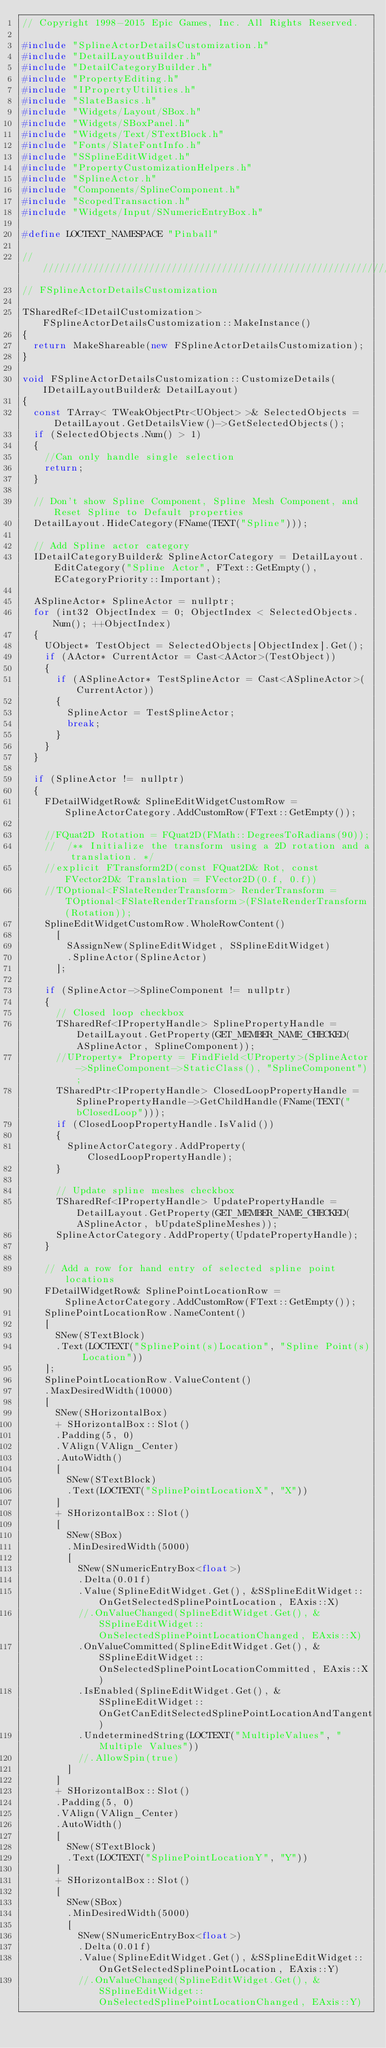Convert code to text. <code><loc_0><loc_0><loc_500><loc_500><_C++_>// Copyright 1998-2015 Epic Games, Inc. All Rights Reserved.

#include "SplineActorDetailsCustomization.h"
#include "DetailLayoutBuilder.h"
#include "DetailCategoryBuilder.h"
#include "PropertyEditing.h"
#include "IPropertyUtilities.h"
#include "SlateBasics.h"
#include "Widgets/Layout/SBox.h"
#include "Widgets/SBoxPanel.h"
#include "Widgets/Text/STextBlock.h"
#include "Fonts/SlateFontInfo.h"
#include "SSplineEditWidget.h"
#include "PropertyCustomizationHelpers.h"
#include "SplineActor.h"
#include "Components/SplineComponent.h"
#include "ScopedTransaction.h"
#include "Widgets/Input/SNumericEntryBox.h"

#define LOCTEXT_NAMESPACE "Pinball"

//////////////////////////////////////////////////////////////////////////
// FSplineActorDetailsCustomization

TSharedRef<IDetailCustomization> FSplineActorDetailsCustomization::MakeInstance()
{
	return MakeShareable(new FSplineActorDetailsCustomization);
}

void FSplineActorDetailsCustomization::CustomizeDetails(IDetailLayoutBuilder& DetailLayout)
{
	const TArray< TWeakObjectPtr<UObject> >& SelectedObjects = DetailLayout.GetDetailsView()->GetSelectedObjects();
	if (SelectedObjects.Num() > 1)
	{
		//Can only handle single selection
		return;
	}

	// Don't show Spline Component, Spline Mesh Component, and Reset Spline to Default properties
	DetailLayout.HideCategory(FName(TEXT("Spline")));

	// Add Spline actor category
	IDetailCategoryBuilder& SplineActorCategory = DetailLayout.EditCategory("Spline Actor", FText::GetEmpty(), ECategoryPriority::Important);

	ASplineActor* SplineActor = nullptr;
	for (int32 ObjectIndex = 0; ObjectIndex < SelectedObjects.Num(); ++ObjectIndex)
	{
		UObject* TestObject = SelectedObjects[ObjectIndex].Get();
		if (AActor* CurrentActor = Cast<AActor>(TestObject))
		{
			if (ASplineActor* TestSplineActor = Cast<ASplineActor>(CurrentActor))
			{
				SplineActor = TestSplineActor;
				break;
			}
		}
	}

	if (SplineActor != nullptr)
	{
		FDetailWidgetRow& SplineEditWidgetCustomRow = SplineActorCategory.AddCustomRow(FText::GetEmpty());

		//FQuat2D Rotation = FQuat2D(FMath::DegreesToRadians(90));
		//	/** Initialize the transform using a 2D rotation and a translation. */
		//explicit FTransform2D(const FQuat2D& Rot, const FVector2D& Translation = FVector2D(0.f, 0.f))
		//TOptional<FSlateRenderTransform> RenderTransform = TOptional<FSlateRenderTransform>(FSlateRenderTransform(Rotation));
		SplineEditWidgetCustomRow.WholeRowContent()
			[
				SAssignNew(SplineEditWidget, SSplineEditWidget)
				.SplineActor(SplineActor)
			];

		if (SplineActor->SplineComponent != nullptr)
		{
			// Closed loop checkbox
			TSharedRef<IPropertyHandle> SplinePropertyHandle = DetailLayout.GetProperty(GET_MEMBER_NAME_CHECKED(ASplineActor, SplineComponent));
			//UProperty* Property = FindField<UProperty>(SplineActor->SplineComponent->StaticClass(), "SplineComponent");
			TSharedPtr<IPropertyHandle> ClosedLoopPropertyHandle = SplinePropertyHandle->GetChildHandle(FName(TEXT("bClosedLoop")));
			if (ClosedLoopPropertyHandle.IsValid())
			{
				SplineActorCategory.AddProperty(ClosedLoopPropertyHandle);
			}

			// Update spline meshes checkbox
			TSharedRef<IPropertyHandle> UpdatePropertyHandle = DetailLayout.GetProperty(GET_MEMBER_NAME_CHECKED(ASplineActor, bUpdateSplineMeshes));
			SplineActorCategory.AddProperty(UpdatePropertyHandle);
		}

		// Add a row for hand entry of selected spline point locations
		FDetailWidgetRow& SplinePointLocationRow = SplineActorCategory.AddCustomRow(FText::GetEmpty());
		SplinePointLocationRow.NameContent()
		[
			SNew(STextBlock)
			.Text(LOCTEXT("SplinePoint(s)Location", "Spline Point(s) Location"))
		];
		SplinePointLocationRow.ValueContent()
		.MaxDesiredWidth(10000)
		[
			SNew(SHorizontalBox)
			+ SHorizontalBox::Slot()
			.Padding(5, 0)
			.VAlign(VAlign_Center)
			.AutoWidth()
			[
				SNew(STextBlock)
				.Text(LOCTEXT("SplinePointLocationX", "X"))
			]
			+ SHorizontalBox::Slot()
			[
				SNew(SBox)
				.MinDesiredWidth(5000)
				[
					SNew(SNumericEntryBox<float>)
					.Delta(0.01f)
					.Value(SplineEditWidget.Get(), &SSplineEditWidget::OnGetSelectedSplinePointLocation, EAxis::X)
					//.OnValueChanged(SplineEditWidget.Get(), &SSplineEditWidget::OnSelectedSplinePointLocationChanged, EAxis::X)
					.OnValueCommitted(SplineEditWidget.Get(), &SSplineEditWidget::OnSelectedSplinePointLocationCommitted, EAxis::X)
					.IsEnabled(SplineEditWidget.Get(), &SSplineEditWidget::OnGetCanEditSelectedSplinePointLocationAndTangent)
					.UndeterminedString(LOCTEXT("MultipleValues", "Multiple Values"))
					//.AllowSpin(true)
				]
			]
			+ SHorizontalBox::Slot()
			.Padding(5, 0)
			.VAlign(VAlign_Center)
			.AutoWidth()
			[
				SNew(STextBlock)
				.Text(LOCTEXT("SplinePointLocationY", "Y"))
			]
			+ SHorizontalBox::Slot()
			[
				SNew(SBox)
				.MinDesiredWidth(5000)
				[
					SNew(SNumericEntryBox<float>)
					.Delta(0.01f)
					.Value(SplineEditWidget.Get(), &SSplineEditWidget::OnGetSelectedSplinePointLocation, EAxis::Y)
					//.OnValueChanged(SplineEditWidget.Get(), &SSplineEditWidget::OnSelectedSplinePointLocationChanged, EAxis::Y)</code> 